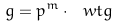<formula> <loc_0><loc_0><loc_500><loc_500>g = p ^ { m } \cdot \ w t { g }</formula> 